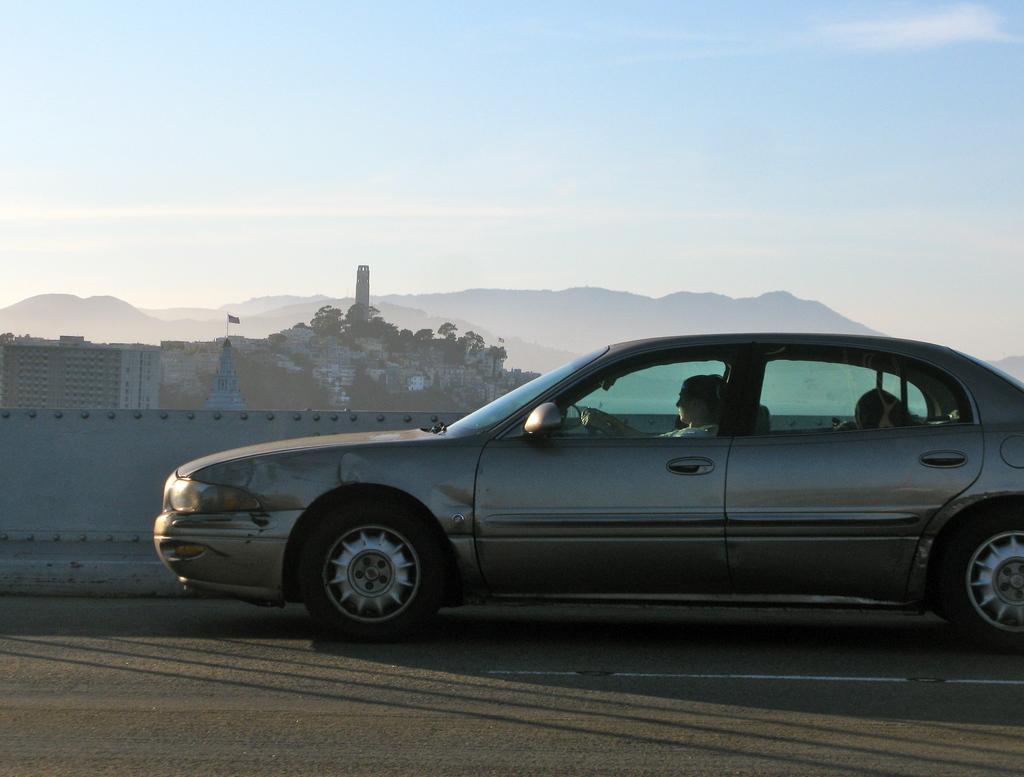Could you give a brief overview of what you see in this image? In the image there is a person sitting in car on a road, behind it there are many buildings and trees on a hill and over the background there are many mountains and above its sky with clouds. 